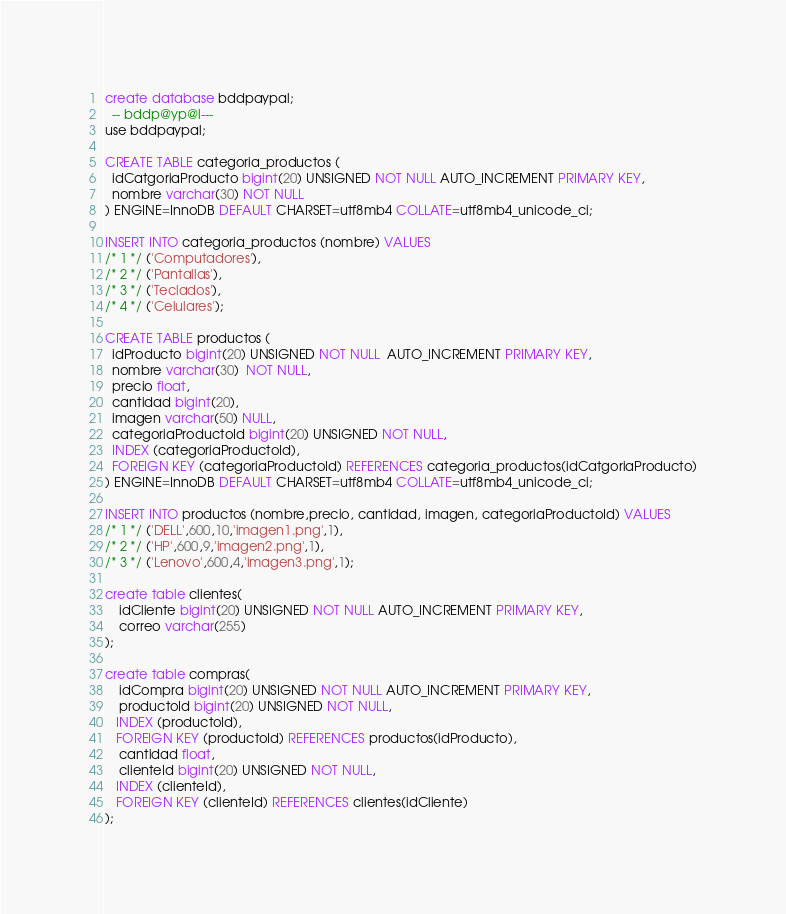Convert code to text. <code><loc_0><loc_0><loc_500><loc_500><_SQL_>create database bddpaypal;
  -- bddp@yp@l---
use bddpaypal;

CREATE TABLE categoria_productos (
  idCatgoriaProducto bigint(20) UNSIGNED NOT NULL AUTO_INCREMENT PRIMARY KEY,
  nombre varchar(30) NOT NULL
) ENGINE=InnoDB DEFAULT CHARSET=utf8mb4 COLLATE=utf8mb4_unicode_ci;

INSERT INTO categoria_productos (nombre) VALUES
/* 1 */ ('Computadores'),
/* 2 */ ('Pantallas'),
/* 3 */ ('Teclados'),
/* 4 */ ('Celulares');

CREATE TABLE productos (
  idProducto bigint(20) UNSIGNED NOT NULL  AUTO_INCREMENT PRIMARY KEY,
  nombre varchar(30)  NOT NULL,
  precio float,
  cantidad bigint(20),
  imagen varchar(50) NULL,
  categoriaProductoId bigint(20) UNSIGNED NOT NULL,
  INDEX (categoriaProductoId),
  FOREIGN KEY (categoriaProductoId) REFERENCES categoria_productos(idCatgoriaProducto)
) ENGINE=InnoDB DEFAULT CHARSET=utf8mb4 COLLATE=utf8mb4_unicode_ci;

INSERT INTO productos (nombre,precio, cantidad, imagen, categoriaProductoId) VALUES
/* 1 */ ('DELL',600,10,'imagen1.png',1),
/* 2 */ ('HP',600,9,'imagen2.png',1),
/* 3 */ ('Lenovo',600,4,'imagen3.png',1);

create table clientes(
	idCliente bigint(20) UNSIGNED NOT NULL AUTO_INCREMENT PRIMARY KEY,
	correo varchar(255)
);

create table compras(
	idCompra bigint(20) UNSIGNED NOT NULL AUTO_INCREMENT PRIMARY KEY,
	productoId bigint(20) UNSIGNED NOT NULL,
   INDEX (productoId),
   FOREIGN KEY (productoId) REFERENCES productos(idProducto),
	cantidad float,
	clienteId bigint(20) UNSIGNED NOT NULL,
   INDEX (clienteId),
   FOREIGN KEY (clienteId) REFERENCES clientes(idCliente)
);
</code> 